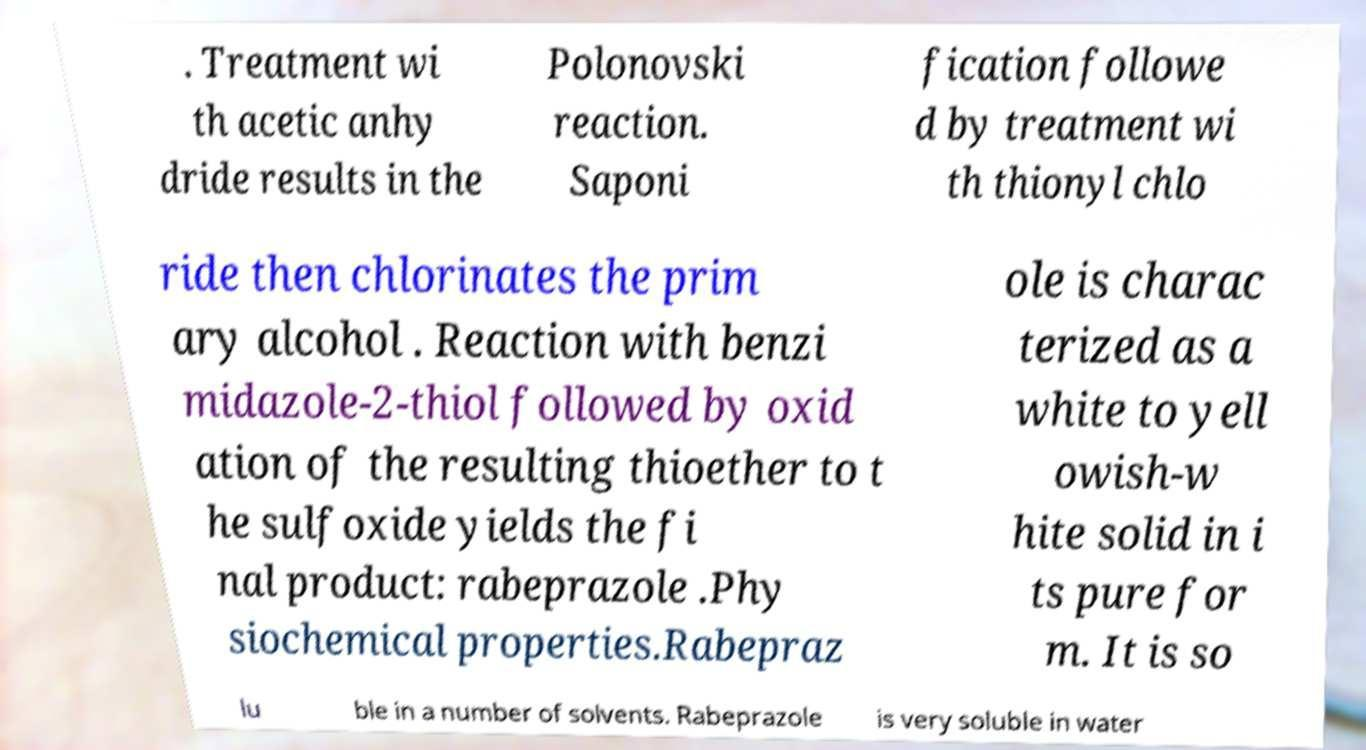Please read and relay the text visible in this image. What does it say? . Treatment wi th acetic anhy dride results in the Polonovski reaction. Saponi fication followe d by treatment wi th thionyl chlo ride then chlorinates the prim ary alcohol . Reaction with benzi midazole-2-thiol followed by oxid ation of the resulting thioether to t he sulfoxide yields the fi nal product: rabeprazole .Phy siochemical properties.Rabepraz ole is charac terized as a white to yell owish-w hite solid in i ts pure for m. It is so lu ble in a number of solvents. Rabeprazole is very soluble in water 